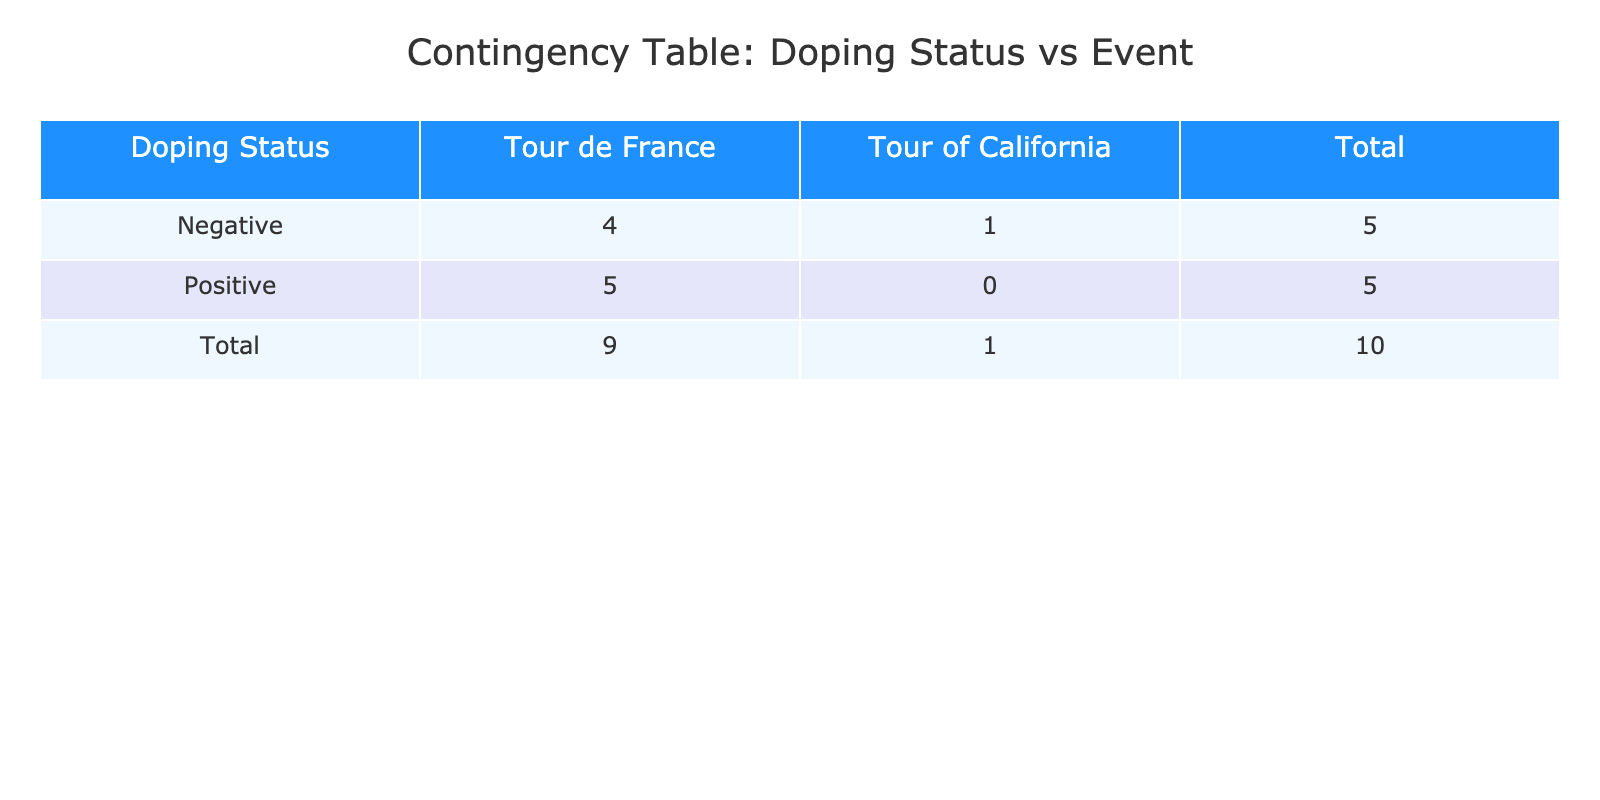What is the total number of cyclists with a positive doping status? In the table, we can look at the row for "Positive" under the "Doping Status" column. There are 5 cyclists listed under this category.
Answer: 5 How many cyclists participated in the Tour de France? To find this, we look at the total count of cyclists listed under the "Tour de France" event in the table. There are 7 participants listed for this event.
Answer: 7 What is the average finish time for cyclists with a negative doping status? The finish times for negative doping status are 145, 210, 150, and 148 minutes. The sum is 145 + 210 + 150 + 148 = 653. There are 4 cyclists, so we calculate the average as 653/4 = 163.25 minutes.
Answer: 163.25 minutes Did any cyclist with a positive doping status have a finish time faster than Lance Armstrong? Looking at Lance Armstrong's finish time of 140 minutes, we check other finish times in the "Positive" row: 150, 155, 160 minutes, all of which are slower than 140 minutes. Therefore, no cyclist with a positive status finished faster than him.
Answer: No How many cyclists had a finish time of 150 minutes or more? To answer this, we check the finish times for each cyclist. The finish times of 150 minutes or more are: 150, 155, 160, 210 minutes; therefore, there are 4 cyclists meeting this criteria.
Answer: 4 Which cyclist had the highest average power among those with a negative doping status? From the negative doping status cyclists, the average powers are: 410 (Chris Froome), 350 (Ryan Hall), 395 (Cadel Evans), and 405 (Vincenzo Nibali). The highest value is 410 watts, which belongs to Chris Froome.
Answer: Chris Froome What is the total number of cyclists and how does that distribute between positive and negative doping status? The total number of cyclists is 10, with 5 having positive doping status and 5 having negative doping status (5 + 5 = 10).
Answer: 10 cyclists (5 positive, 5 negative) Is there any cyclist who finished the Tour de France faster than 145 minutes? Upon examination, Lance Armstrong finished at 140 minutes, which is faster than 145 minutes. Therefore, he is a cyclist who exceeds this time.
Answer: Yes 